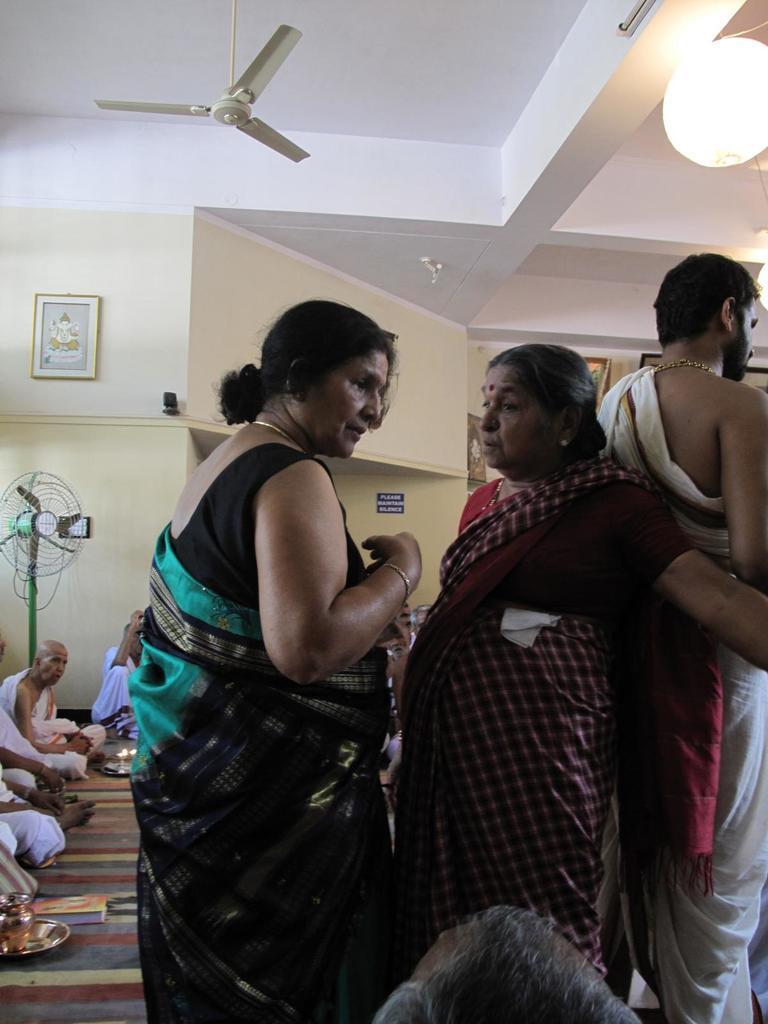Can you describe this image briefly? In this image I can see a woman wearing black and green saree and a another woman wearing maroon saree and a man wearing white dress are standing and in the background I can see few people sitting on the floor, a plate and a book on the floor, a table fan, the wall, a photo frame attached to the wall, a lamp and the fan. 